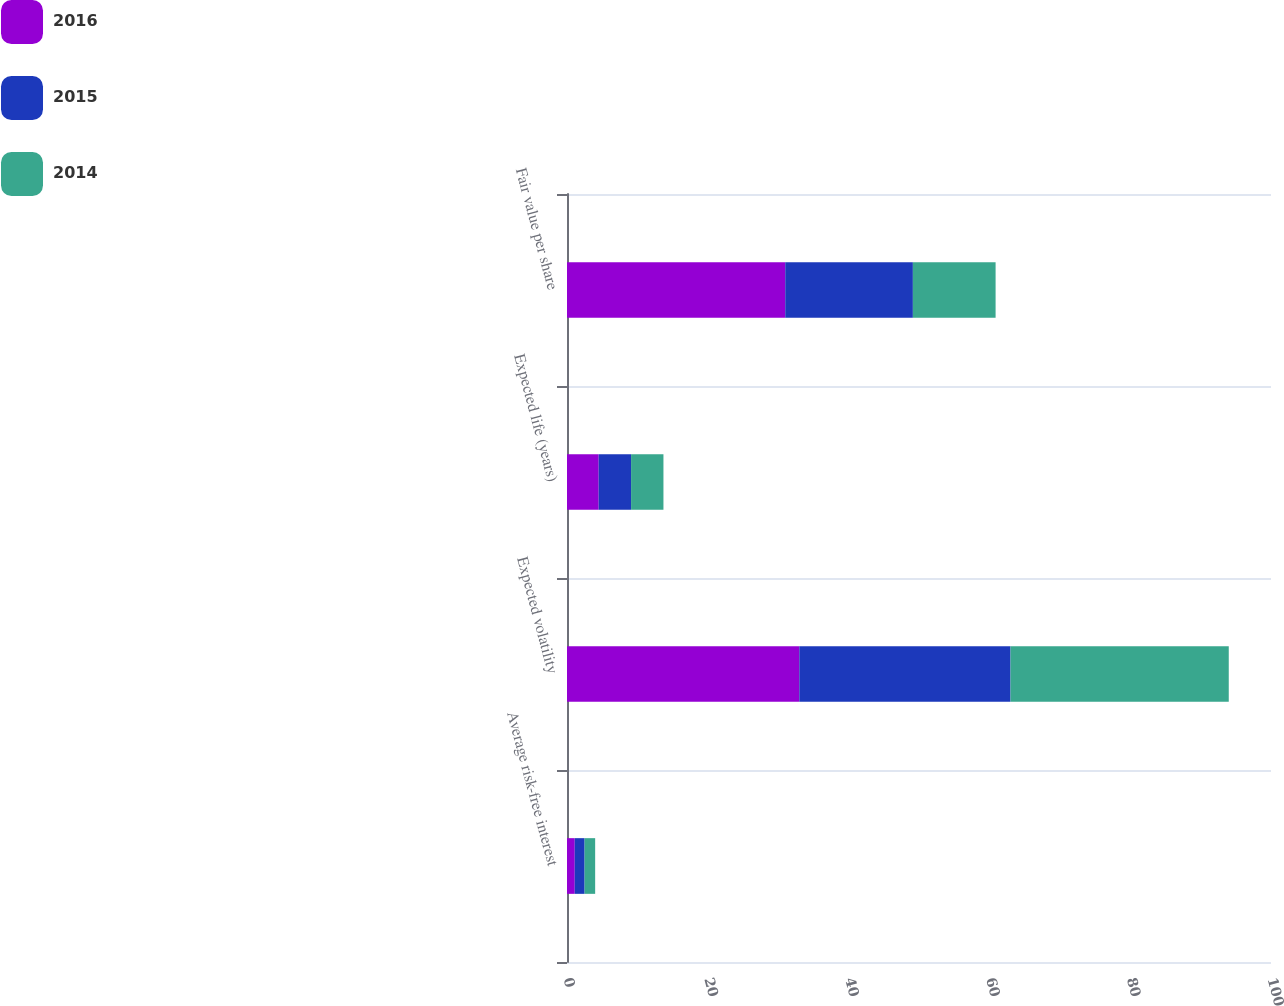Convert chart to OTSL. <chart><loc_0><loc_0><loc_500><loc_500><stacked_bar_chart><ecel><fcel>Average risk-free interest<fcel>Expected volatility<fcel>Expected life (years)<fcel>Fair value per share<nl><fcel>2016<fcel>1.1<fcel>33<fcel>4.5<fcel>31<nl><fcel>2015<fcel>1.4<fcel>30<fcel>4.6<fcel>18.13<nl><fcel>2014<fcel>1.5<fcel>31<fcel>4.6<fcel>11.75<nl></chart> 